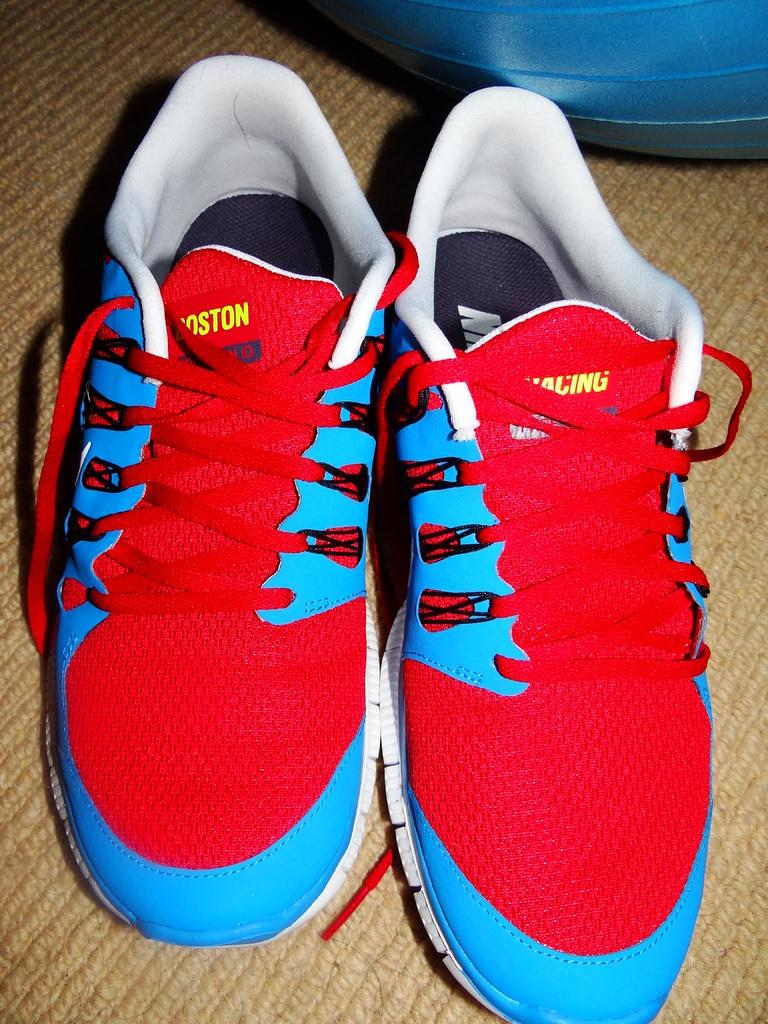What type of footwear is visible in the image? There is a pair of shoes in the image. What colors are used in the design of the shoes? The shoes have a red and blue color combination. Are there any words or text on the shoes? Yes, the shoes have text on them. What can be seen behind the shoes in the image? There is an object behind the shoes. What flavor of ice cream is being advertised on the shoes? There is no ice cream or advertisement present on the shoes; they only have text on them. 